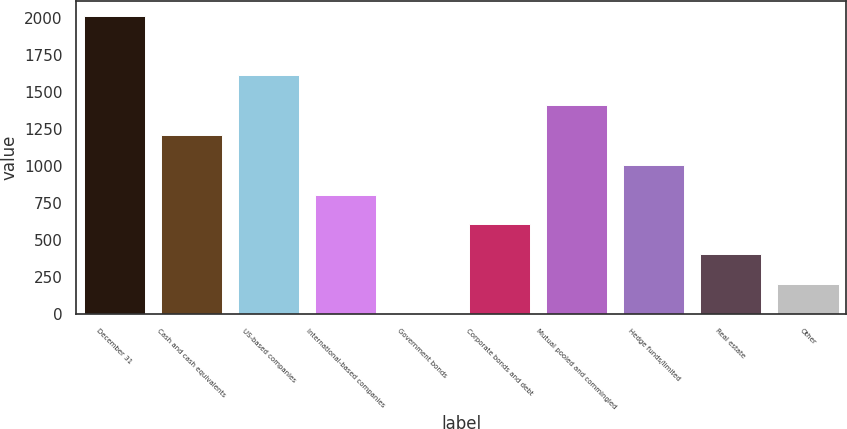Convert chart. <chart><loc_0><loc_0><loc_500><loc_500><bar_chart><fcel>December 31<fcel>Cash and cash equivalents<fcel>US-based companies<fcel>International-based companies<fcel>Government bonds<fcel>Corporate bonds and debt<fcel>Mutual pooled and commingled<fcel>Hedge funds/limited<fcel>Real estate<fcel>Other<nl><fcel>2017<fcel>1211<fcel>1614<fcel>808<fcel>2<fcel>606.5<fcel>1412.5<fcel>1009.5<fcel>405<fcel>203.5<nl></chart> 